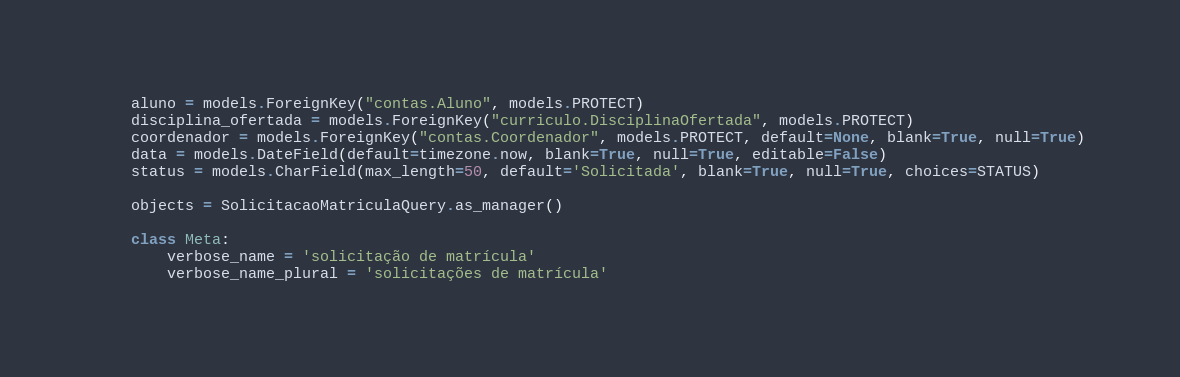Convert code to text. <code><loc_0><loc_0><loc_500><loc_500><_Python_>    aluno = models.ForeignKey("contas.Aluno", models.PROTECT)
    disciplina_ofertada = models.ForeignKey("curriculo.DisciplinaOfertada", models.PROTECT)
    coordenador = models.ForeignKey("contas.Coordenador", models.PROTECT, default=None, blank=True, null=True)
    data = models.DateField(default=timezone.now, blank=True, null=True, editable=False)
    status = models.CharField(max_length=50, default='Solicitada', blank=True, null=True, choices=STATUS)

    objects = SolicitacaoMatriculaQuery.as_manager()

    class Meta:
        verbose_name = 'solicitação de matrícula'
        verbose_name_plural = 'solicitações de matrícula'</code> 